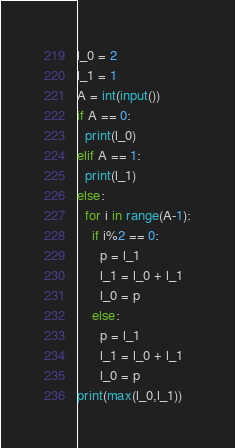<code> <loc_0><loc_0><loc_500><loc_500><_Python_>l_0 = 2
l_1 = 1
A = int(input())
if A == 0:
  print(l_0)
elif A == 1:
  print(l_1)
else:
  for i in range(A-1):
    if i%2 == 0:
      p = l_1
      l_1 = l_0 + l_1
      l_0 = p
    else:
      p = l_1
      l_1 = l_0 + l_1
      l_0 = p
print(max(l_0,l_1))</code> 